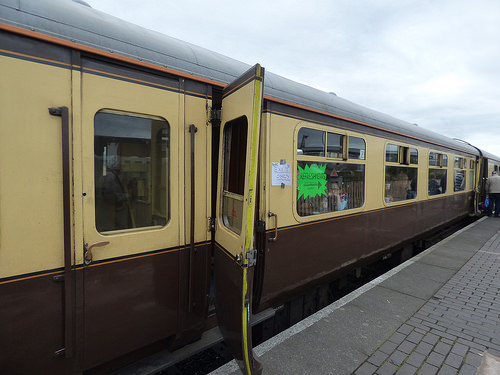<image>
Is there a train to the left of the platform? Yes. From this viewpoint, the train is positioned to the left side relative to the platform. 